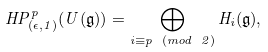Convert formula to latex. <formula><loc_0><loc_0><loc_500><loc_500>H P ^ { p } _ { ( \epsilon , 1 ) } ( U ( \mathfrak { g } ) ) = \bigoplus _ { i \equiv p \ ( m o d \ 2 ) } H _ { i } ( \mathfrak { g } ) ,</formula> 